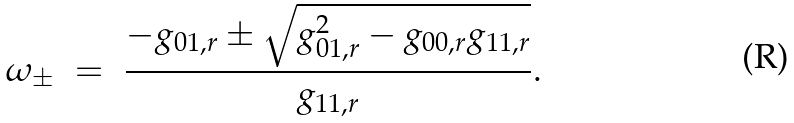Convert formula to latex. <formula><loc_0><loc_0><loc_500><loc_500>\omega _ { \pm } \ = \ \frac { - g _ { 0 1 , r } \pm \sqrt { g _ { 0 1 , r } ^ { 2 } - g _ { 0 0 , r } g _ { 1 1 , r } } } { g _ { 1 1 , r } } .</formula> 